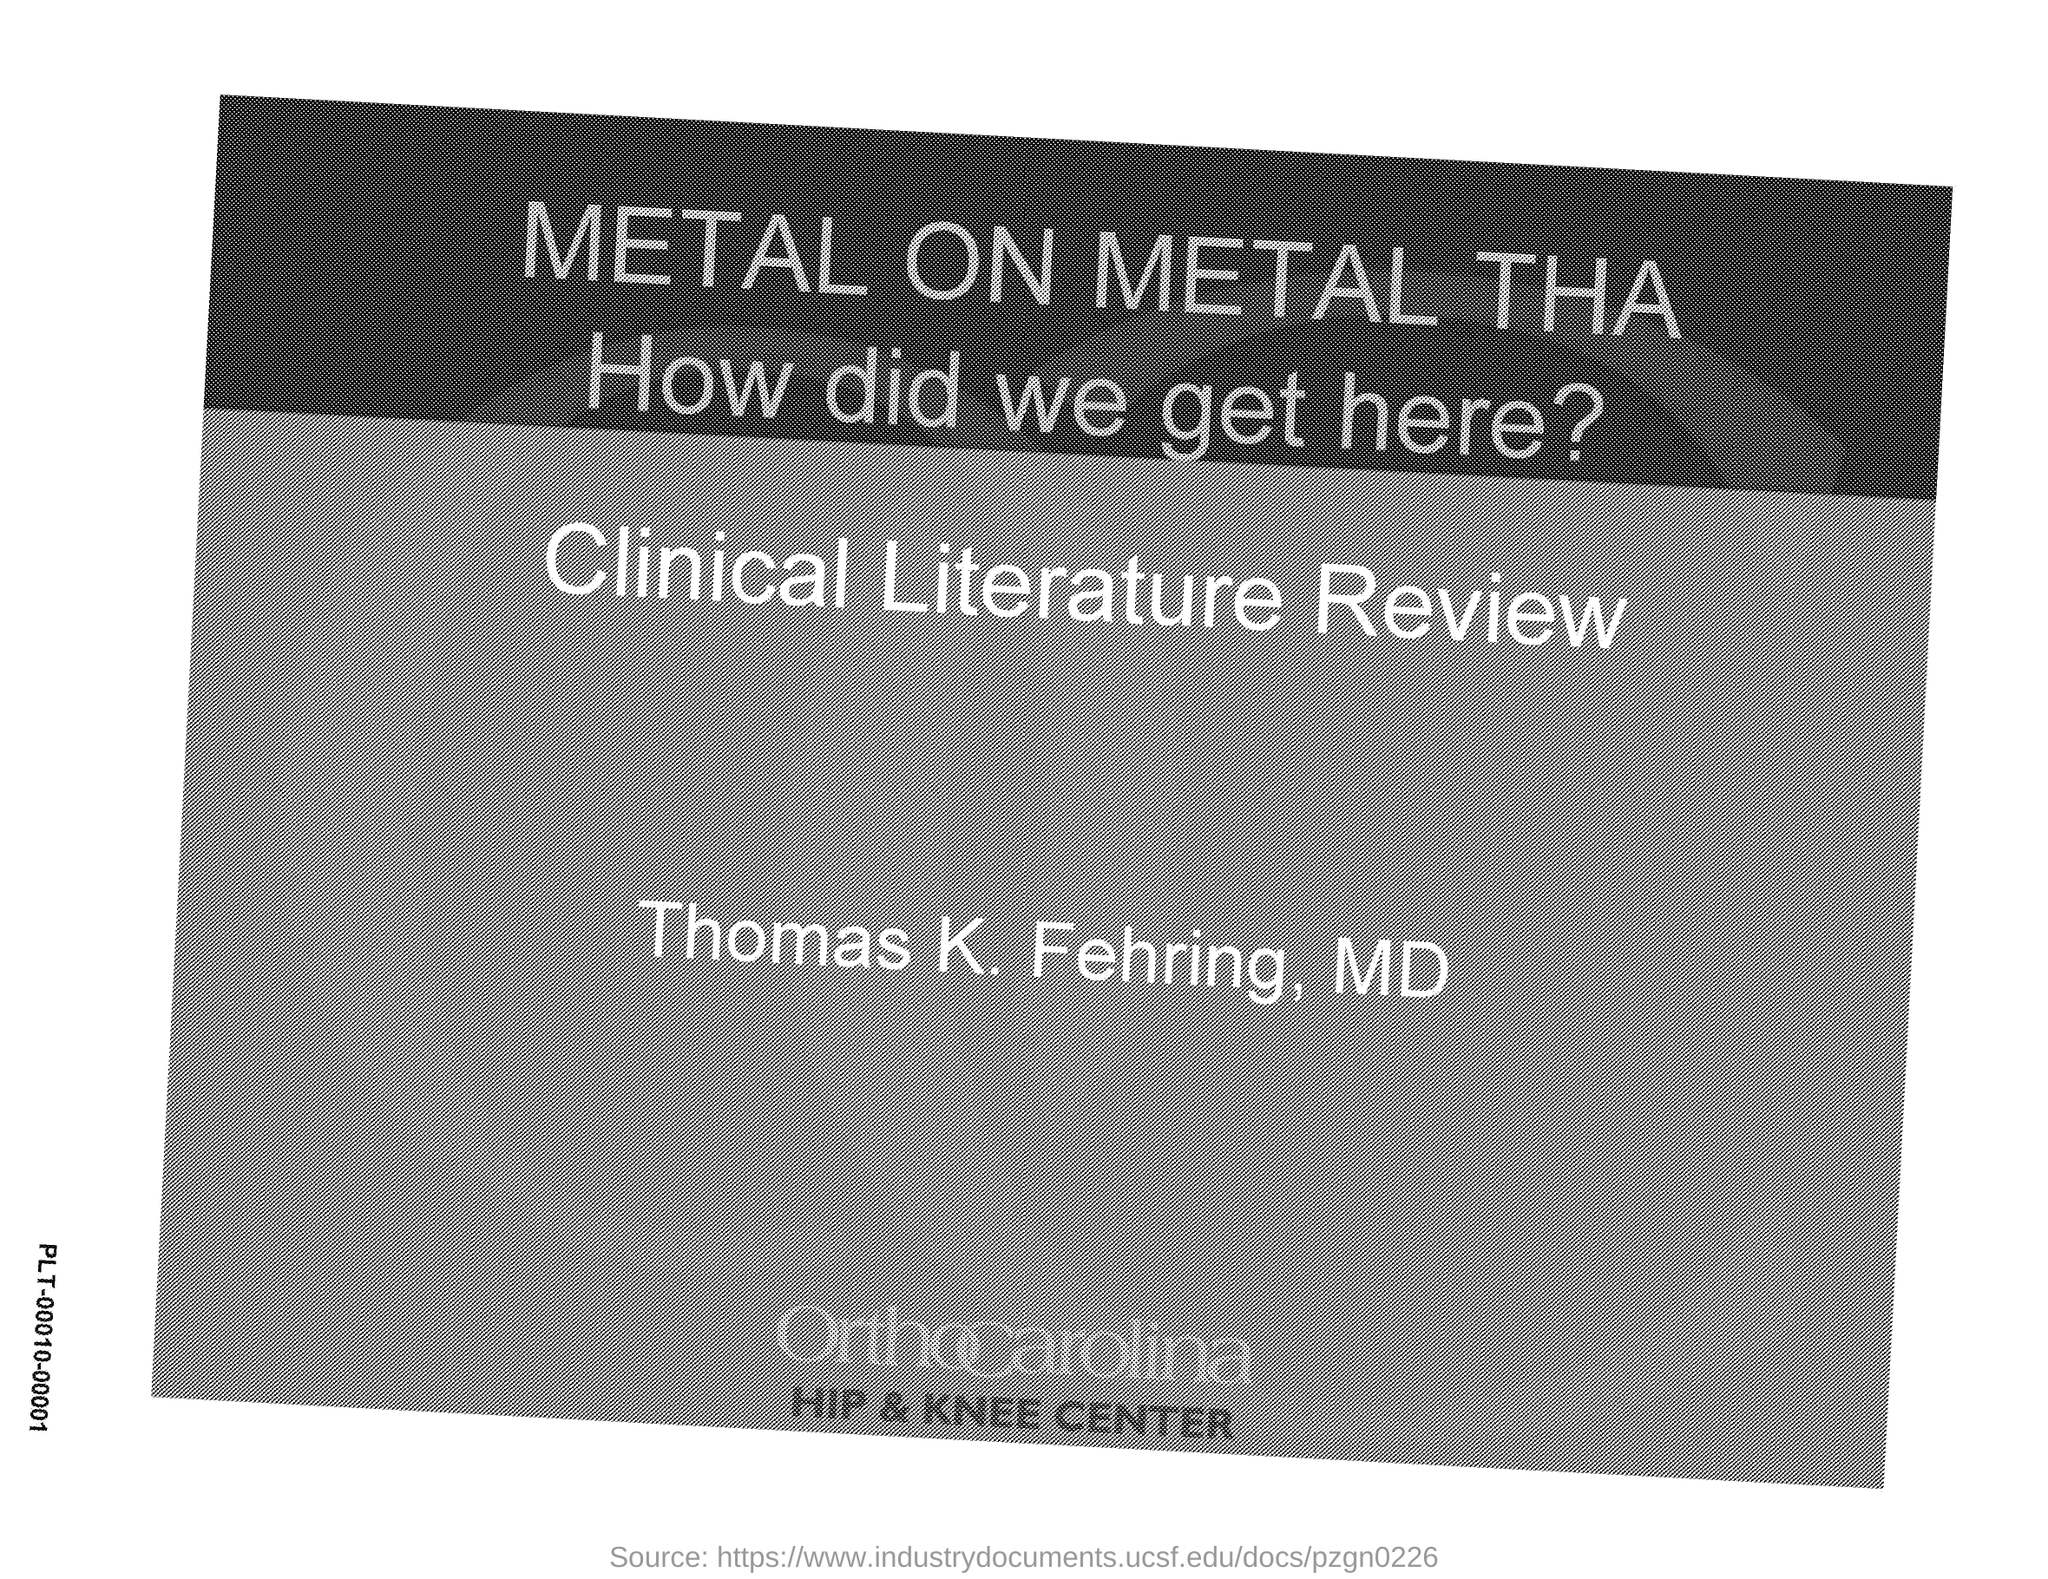Indicate a few pertinent items in this graphic. The title of the document is 'Metal On Metal Thataway'. 